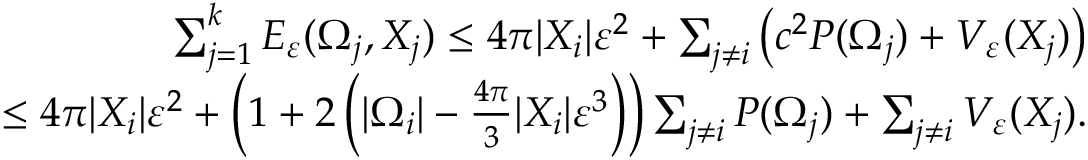Convert formula to latex. <formula><loc_0><loc_0><loc_500><loc_500>\begin{array} { r } { \sum _ { j = 1 } ^ { k } E _ { \varepsilon } ( \Omega _ { j } , X _ { j } ) \leq 4 \pi | X _ { i } | \varepsilon ^ { 2 } + \sum _ { j \neq i } \left ( c ^ { 2 } P ( \Omega _ { j } ) + V _ { \varepsilon } ( X _ { j } ) \right ) } \\ { \leq 4 \pi | X _ { i } | \varepsilon ^ { 2 } + \left ( 1 + 2 \left ( | \Omega _ { i } | - \frac { 4 \pi } { 3 } | X _ { i } | \varepsilon ^ { 3 } \right ) \right ) \sum _ { j \neq i } P ( \Omega _ { j } ) + \sum _ { j \neq i } V _ { \varepsilon } ( X _ { j } ) . } \end{array}</formula> 